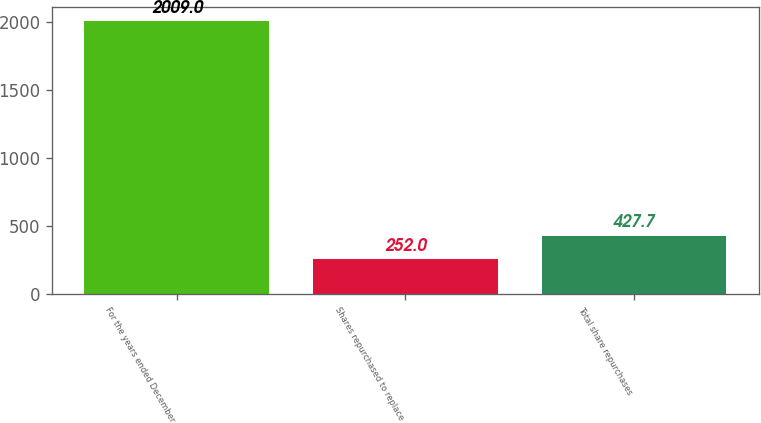Convert chart. <chart><loc_0><loc_0><loc_500><loc_500><bar_chart><fcel>For the years ended December<fcel>Shares repurchased to replace<fcel>Total share repurchases<nl><fcel>2009<fcel>252<fcel>427.7<nl></chart> 